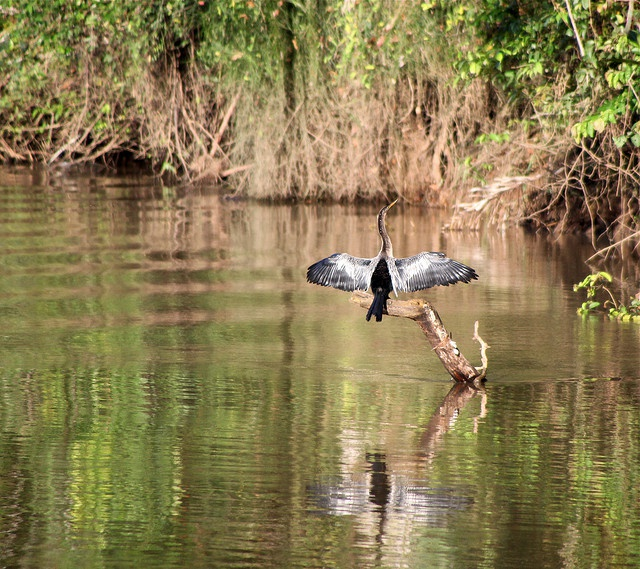Describe the objects in this image and their specific colors. I can see a bird in olive, lightgray, darkgray, gray, and black tones in this image. 